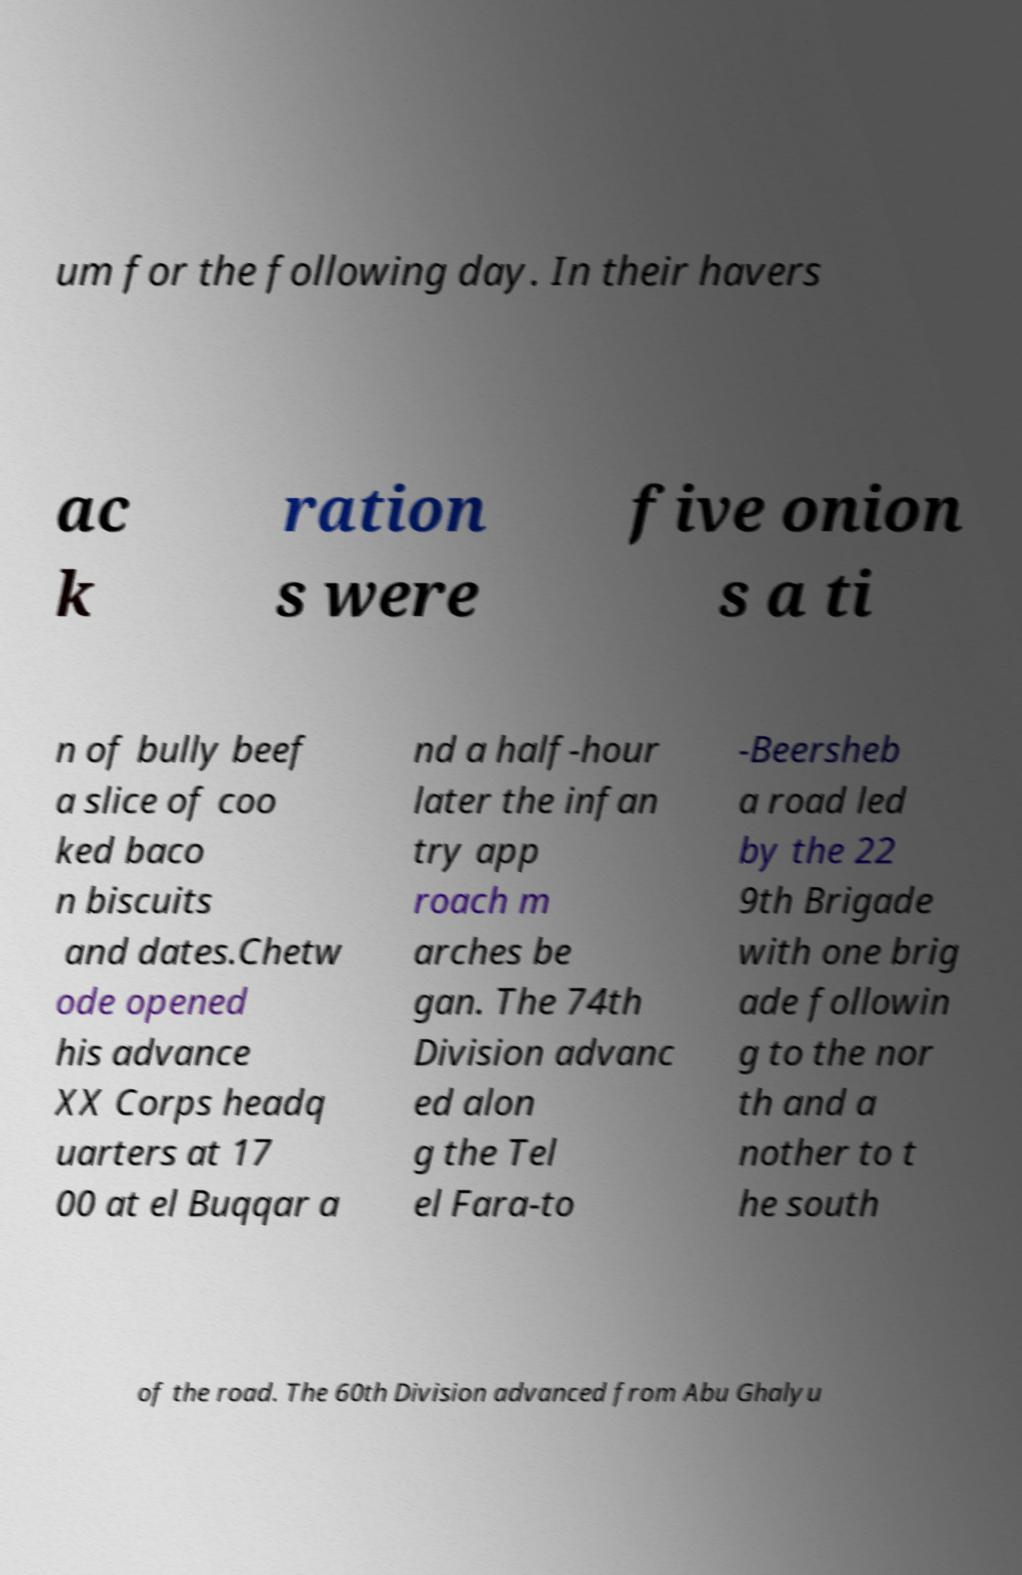Could you assist in decoding the text presented in this image and type it out clearly? um for the following day. In their havers ac k ration s were five onion s a ti n of bully beef a slice of coo ked baco n biscuits and dates.Chetw ode opened his advance XX Corps headq uarters at 17 00 at el Buqqar a nd a half-hour later the infan try app roach m arches be gan. The 74th Division advanc ed alon g the Tel el Fara-to -Beersheb a road led by the 22 9th Brigade with one brig ade followin g to the nor th and a nother to t he south of the road. The 60th Division advanced from Abu Ghalyu 